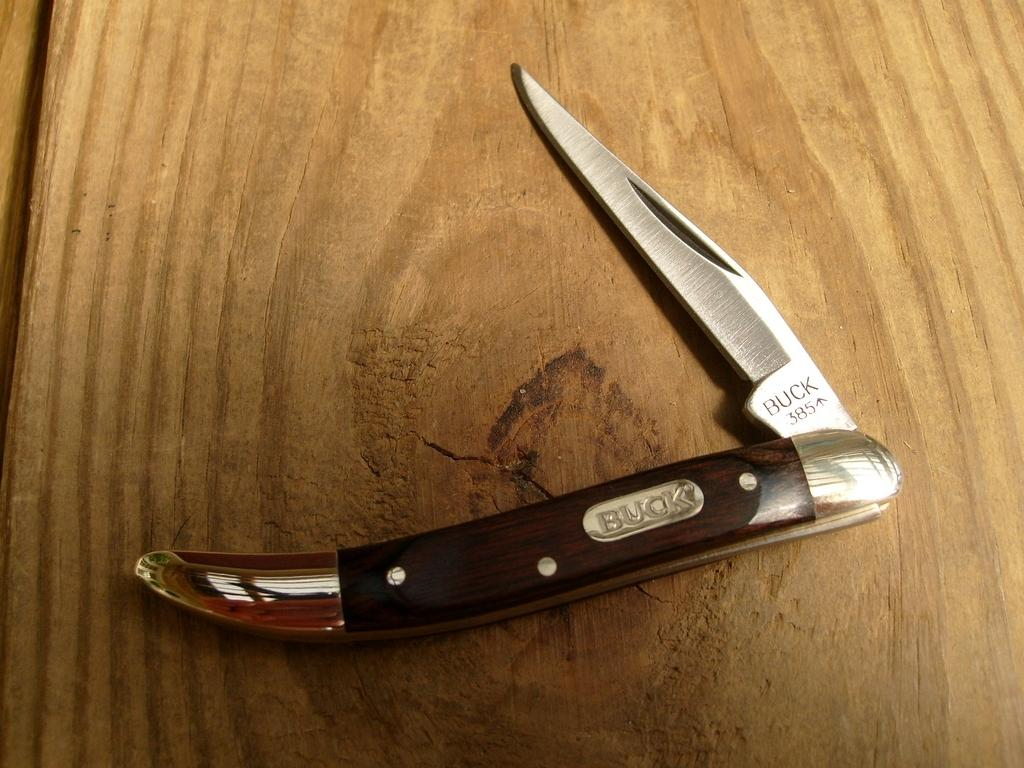What type of surface is visible in the image? There is a wooden surface in the image. What object is placed on the wooden surface? There is a utility knife on the wooden surface. What type of cough medicine is visible on the wooden surface? There is no cough medicine present in the image; it only features a wooden surface and a utility knife. 